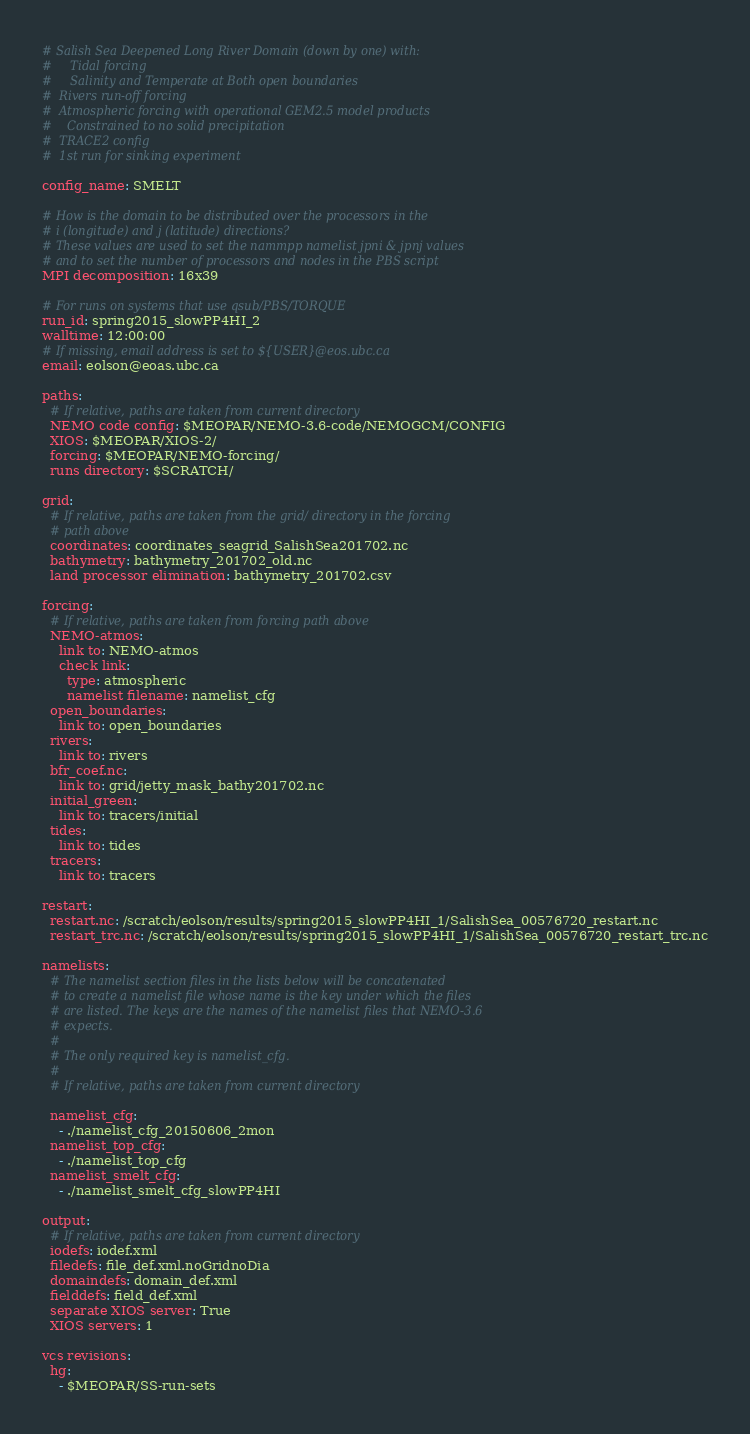<code> <loc_0><loc_0><loc_500><loc_500><_YAML_># Salish Sea Deepened Long River Domain (down by one) with:
#     Tidal forcing
#     Salinity and Temperate at Both open boundaries
#  Rivers run-off forcing
#  Atmospheric forcing with operational GEM2.5 model products
#    Constrained to no solid precipitation
#  TRACE2 config
#  1st run for sinking experiment

config_name: SMELT

# How is the domain to be distributed over the processors in the
# i (longitude) and j (latitude) directions?
# These values are used to set the nammpp namelist jpni & jpnj values
# and to set the number of processors and nodes in the PBS script
MPI decomposition: 16x39

# For runs on systems that use qsub/PBS/TORQUE
run_id: spring2015_slowPP4HI_2
walltime: 12:00:00
# If missing, email address is set to ${USER}@eos.ubc.ca
email: eolson@eoas.ubc.ca

paths:
  # If relative, paths are taken from current directory
  NEMO code config: $MEOPAR/NEMO-3.6-code/NEMOGCM/CONFIG
  XIOS: $MEOPAR/XIOS-2/
  forcing: $MEOPAR/NEMO-forcing/
  runs directory: $SCRATCH/

grid:
  # If relative, paths are taken from the grid/ directory in the forcing
  # path above
  coordinates: coordinates_seagrid_SalishSea201702.nc
  bathymetry: bathymetry_201702_old.nc
  land processor elimination: bathymetry_201702.csv

forcing:
  # If relative, paths are taken from forcing path above
  NEMO-atmos:
    link to: NEMO-atmos
    check link:
      type: atmospheric
      namelist filename: namelist_cfg
  open_boundaries:
    link to: open_boundaries
  rivers:
    link to: rivers
  bfr_coef.nc:
    link to: grid/jetty_mask_bathy201702.nc
  initial_green:
    link to: tracers/initial
  tides:
    link to: tides
  tracers:
    link to: tracers

restart:
  restart.nc: /scratch/eolson/results/spring2015_slowPP4HI_1/SalishSea_00576720_restart.nc
  restart_trc.nc: /scratch/eolson/results/spring2015_slowPP4HI_1/SalishSea_00576720_restart_trc.nc

namelists:
  # The namelist section files in the lists below will be concatenated
  # to create a namelist file whose name is the key under which the files
  # are listed. The keys are the names of the namelist files that NEMO-3.6
  # expects.
  #
  # The only required key is namelist_cfg.
  #
  # If relative, paths are taken from current directory

  namelist_cfg:
    - ./namelist_cfg_20150606_2mon
  namelist_top_cfg:
    - ./namelist_top_cfg
  namelist_smelt_cfg:
    - ./namelist_smelt_cfg_slowPP4HI

output:
  # If relative, paths are taken from current directory
  iodefs: iodef.xml
  filedefs: file_def.xml.noGridnoDia
  domaindefs: domain_def.xml
  fielddefs: field_def.xml
  separate XIOS server: True
  XIOS servers: 1

vcs revisions:
  hg: 
    - $MEOPAR/SS-run-sets
</code> 